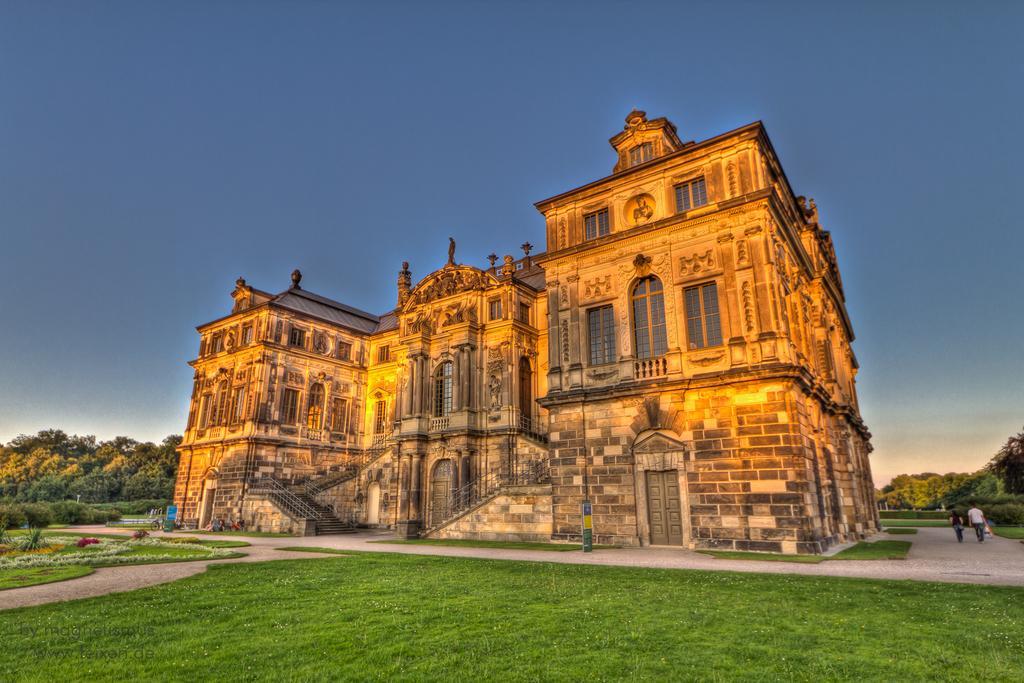Could you give a brief overview of what you see in this image? In this image, we can see a building. There are some trees in the bottom left of the image. There are two persons on the bottom right of the image walking on the path. In the background of the image, there is a sky. 